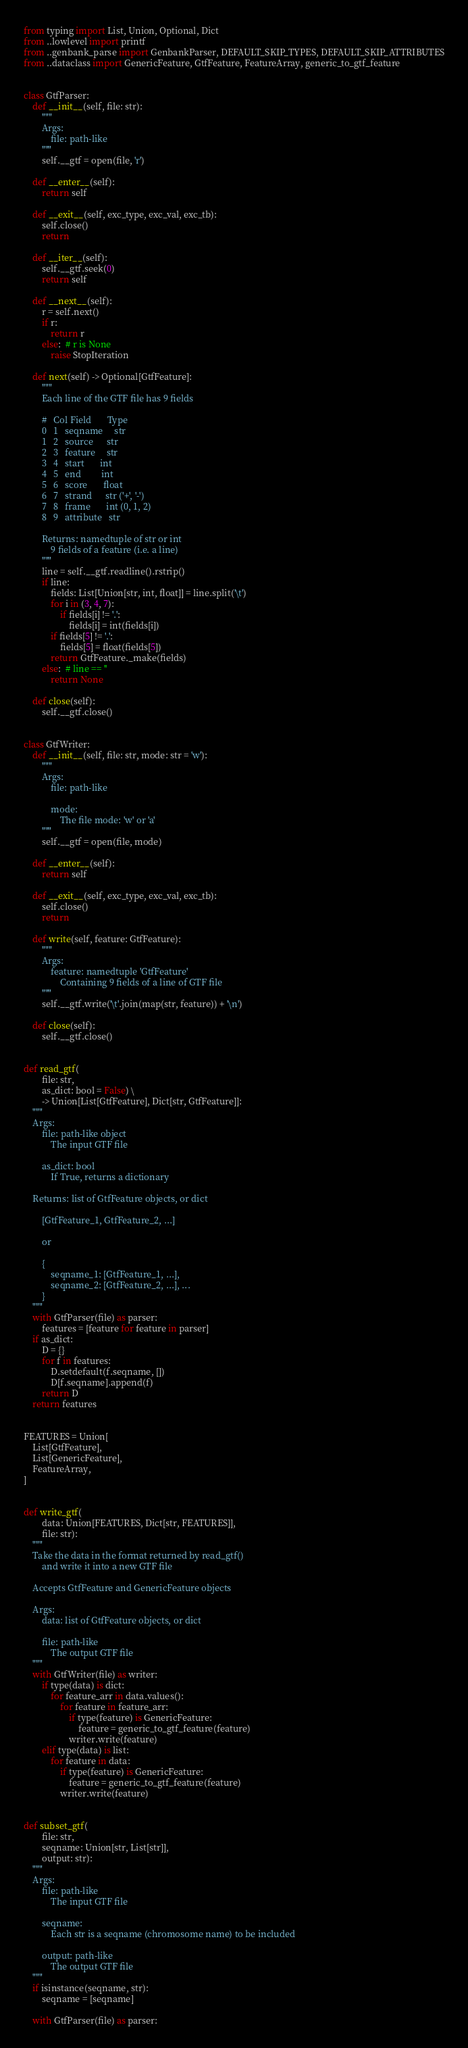<code> <loc_0><loc_0><loc_500><loc_500><_Python_>from typing import List, Union, Optional, Dict
from ..lowlevel import printf
from ..genbank_parse import GenbankParser, DEFAULT_SKIP_TYPES, DEFAULT_SKIP_ATTRIBUTES
from ..dataclass import GenericFeature, GtfFeature, FeatureArray, generic_to_gtf_feature


class GtfParser:
    def __init__(self, file: str):
        """
        Args:
            file: path-like
        """
        self.__gtf = open(file, 'r')

    def __enter__(self):
        return self

    def __exit__(self, exc_type, exc_val, exc_tb):
        self.close()
        return

    def __iter__(self):
        self.__gtf.seek(0)
        return self

    def __next__(self):
        r = self.next()
        if r:
            return r
        else:  # r is None
            raise StopIteration

    def next(self) -> Optional[GtfFeature]:
        """
        Each line of the GTF file has 9 fields

        #   Col	Field       Type
        0   1   seqname     str
        1   2   source      str
        2   3   feature     str
        3   4   start       int
        4   5   end         int
        5   6   score       float
        6   7   strand      str ('+', '-')
        7   8   frame       int (0, 1, 2)
        8   9   attribute   str

        Returns: namedtuple of str or int
            9 fields of a feature (i.e. a line)
        """
        line = self.__gtf.readline().rstrip()
        if line:
            fields: List[Union[str, int, float]] = line.split('\t')
            for i in (3, 4, 7):
                if fields[i] != '.':
                    fields[i] = int(fields[i])
            if fields[5] != '.':
                fields[5] = float(fields[5])
            return GtfFeature._make(fields)
        else:  # line == ''
            return None

    def close(self):
        self.__gtf.close()


class GtfWriter:
    def __init__(self, file: str, mode: str = 'w'):
        """
        Args:
            file: path-like

            mode:
                The file mode: 'w' or 'a'
        """
        self.__gtf = open(file, mode)

    def __enter__(self):
        return self

    def __exit__(self, exc_type, exc_val, exc_tb):
        self.close()
        return

    def write(self, feature: GtfFeature):
        """
        Args:
            feature: namedtuple 'GtfFeature'
                Containing 9 fields of a line of GTF file
        """
        self.__gtf.write('\t'.join(map(str, feature)) + '\n')

    def close(self):
        self.__gtf.close()


def read_gtf(
        file: str,
        as_dict: bool = False) \
        -> Union[List[GtfFeature], Dict[str, GtfFeature]]:
    """
    Args:
        file: path-like object
            The input GTF file

        as_dict: bool
            If True, returns a dictionary

    Returns: list of GtfFeature objects, or dict

        [GtfFeature_1, GtfFeature_2, ...]

        or

        {
            seqname_1: [GtfFeature_1, ...],
            seqname_2: [GtfFeature_2, ...], ...
        }
    """
    with GtfParser(file) as parser:
        features = [feature for feature in parser]
    if as_dict:
        D = {}
        for f in features:
            D.setdefault(f.seqname, [])
            D[f.seqname].append(f)
        return D
    return features


FEATURES = Union[
    List[GtfFeature],
    List[GenericFeature],
    FeatureArray,
]


def write_gtf(
        data: Union[FEATURES, Dict[str, FEATURES]],
        file: str):
    """
    Take the data in the format returned by read_gtf()
        and write it into a new GTF file

    Accepts GtfFeature and GenericFeature objects

    Args:
        data: list of GtfFeature objects, or dict

        file: path-like
            The output GTF file
    """
    with GtfWriter(file) as writer:
        if type(data) is dict:
            for feature_arr in data.values():
                for feature in feature_arr:
                    if type(feature) is GenericFeature:
                        feature = generic_to_gtf_feature(feature)
                    writer.write(feature)
        elif type(data) is list:
            for feature in data:
                if type(feature) is GenericFeature:
                    feature = generic_to_gtf_feature(feature)
                writer.write(feature)


def subset_gtf(
        file: str,
        seqname: Union[str, List[str]],
        output: str):
    """
    Args:
        file: path-like
            The input GTF file

        seqname:
            Each str is a seqname (chromosome name) to be included

        output: path-like
            The output GTF file
    """
    if isinstance(seqname, str):
        seqname = [seqname]

    with GtfParser(file) as parser:</code> 